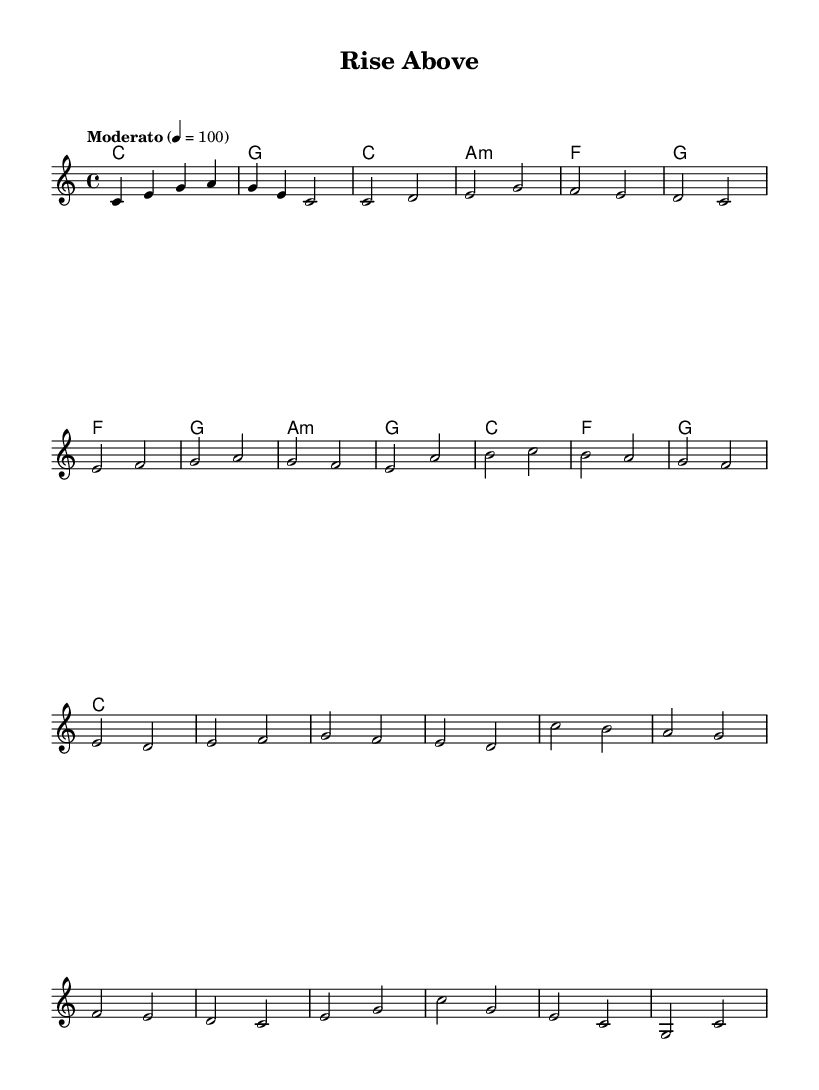What is the key signature of this music? The key signature is C major, which has no sharps or flats.
Answer: C major What is the time signature of this music? The time signature is indicated as 4/4, which means there are four beats in each measure.
Answer: 4/4 What is the tempo marking for this piece? The tempo marking indicates a moderate speed with a metronome marking of 100 beats per minute.
Answer: Moderato 4 = 100 How many measures are there in the chorus? The chorus consists of four measures, delineated clearly in the music.
Answer: 4 What is the first note of the melody? The first note of the melody is C, which is notated as the lowest note in the introductory measure.
Answer: C What is the chord for the first measure? The chord for the first measure is C major, indicated at the beginning of the score.
Answer: C What type of music is this piece classified as? This piece is classified as an uplifting soundtrack designed for educational documentaries focusing on overcoming adversity.
Answer: Uplifting soundtrack 